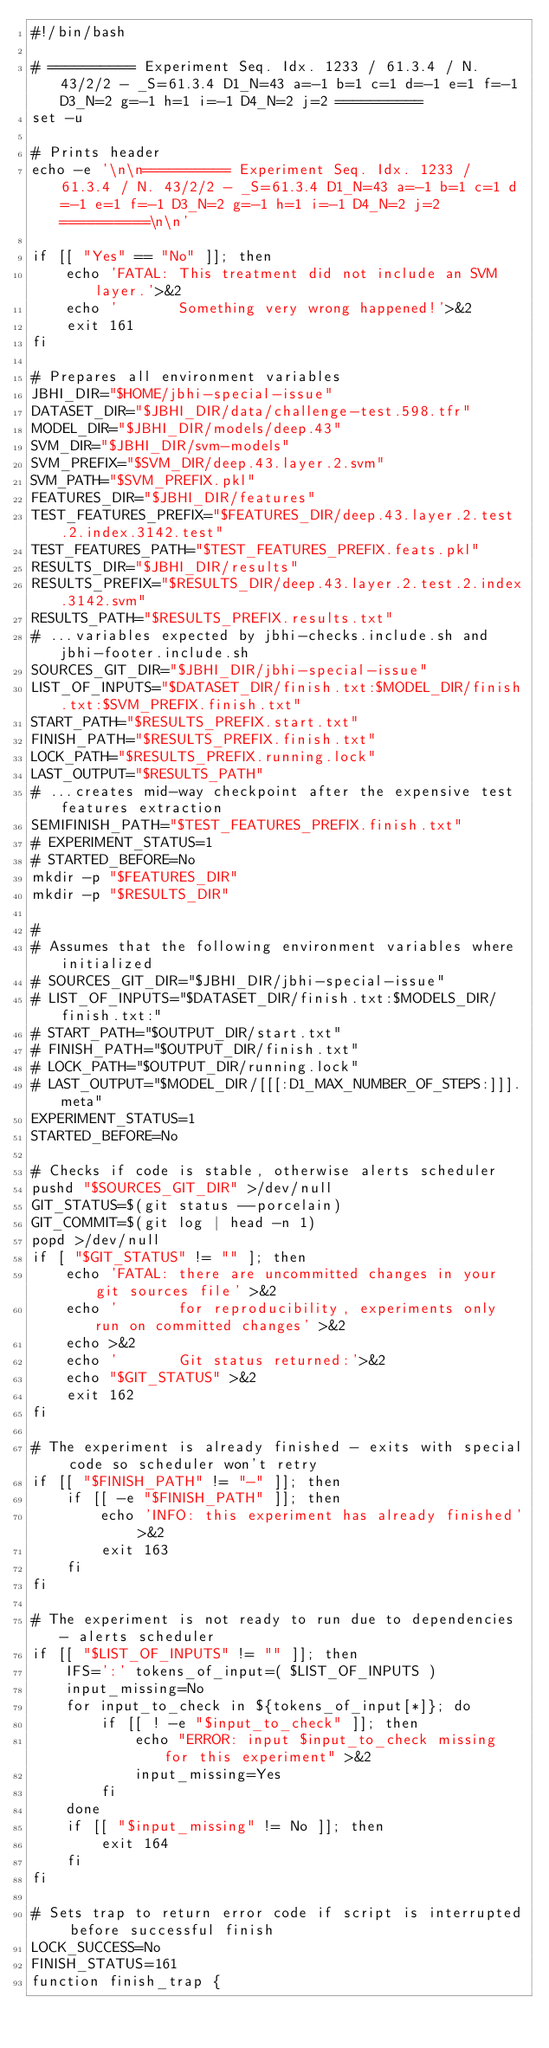<code> <loc_0><loc_0><loc_500><loc_500><_Bash_>#!/bin/bash

# ========== Experiment Seq. Idx. 1233 / 61.3.4 / N. 43/2/2 - _S=61.3.4 D1_N=43 a=-1 b=1 c=1 d=-1 e=1 f=-1 D3_N=2 g=-1 h=1 i=-1 D4_N=2 j=2 ==========
set -u

# Prints header
echo -e '\n\n========== Experiment Seq. Idx. 1233 / 61.3.4 / N. 43/2/2 - _S=61.3.4 D1_N=43 a=-1 b=1 c=1 d=-1 e=1 f=-1 D3_N=2 g=-1 h=1 i=-1 D4_N=2 j=2 ==========\n\n'

if [[ "Yes" == "No" ]]; then
    echo 'FATAL: This treatment did not include an SVM layer.'>&2
    echo '       Something very wrong happened!'>&2
    exit 161
fi

# Prepares all environment variables
JBHI_DIR="$HOME/jbhi-special-issue"
DATASET_DIR="$JBHI_DIR/data/challenge-test.598.tfr"
MODEL_DIR="$JBHI_DIR/models/deep.43"
SVM_DIR="$JBHI_DIR/svm-models"
SVM_PREFIX="$SVM_DIR/deep.43.layer.2.svm"
SVM_PATH="$SVM_PREFIX.pkl"
FEATURES_DIR="$JBHI_DIR/features"
TEST_FEATURES_PREFIX="$FEATURES_DIR/deep.43.layer.2.test.2.index.3142.test"
TEST_FEATURES_PATH="$TEST_FEATURES_PREFIX.feats.pkl"
RESULTS_DIR="$JBHI_DIR/results"
RESULTS_PREFIX="$RESULTS_DIR/deep.43.layer.2.test.2.index.3142.svm"
RESULTS_PATH="$RESULTS_PREFIX.results.txt"
# ...variables expected by jbhi-checks.include.sh and jbhi-footer.include.sh
SOURCES_GIT_DIR="$JBHI_DIR/jbhi-special-issue"
LIST_OF_INPUTS="$DATASET_DIR/finish.txt:$MODEL_DIR/finish.txt:$SVM_PREFIX.finish.txt"
START_PATH="$RESULTS_PREFIX.start.txt"
FINISH_PATH="$RESULTS_PREFIX.finish.txt"
LOCK_PATH="$RESULTS_PREFIX.running.lock"
LAST_OUTPUT="$RESULTS_PATH"
# ...creates mid-way checkpoint after the expensive test features extraction
SEMIFINISH_PATH="$TEST_FEATURES_PREFIX.finish.txt"
# EXPERIMENT_STATUS=1
# STARTED_BEFORE=No
mkdir -p "$FEATURES_DIR"
mkdir -p "$RESULTS_DIR"

#
# Assumes that the following environment variables where initialized
# SOURCES_GIT_DIR="$JBHI_DIR/jbhi-special-issue"
# LIST_OF_INPUTS="$DATASET_DIR/finish.txt:$MODELS_DIR/finish.txt:"
# START_PATH="$OUTPUT_DIR/start.txt"
# FINISH_PATH="$OUTPUT_DIR/finish.txt"
# LOCK_PATH="$OUTPUT_DIR/running.lock"
# LAST_OUTPUT="$MODEL_DIR/[[[:D1_MAX_NUMBER_OF_STEPS:]]].meta"
EXPERIMENT_STATUS=1
STARTED_BEFORE=No

# Checks if code is stable, otherwise alerts scheduler
pushd "$SOURCES_GIT_DIR" >/dev/null
GIT_STATUS=$(git status --porcelain)
GIT_COMMIT=$(git log | head -n 1)
popd >/dev/null
if [ "$GIT_STATUS" != "" ]; then
    echo 'FATAL: there are uncommitted changes in your git sources file' >&2
    echo '       for reproducibility, experiments only run on committed changes' >&2
    echo >&2
    echo '       Git status returned:'>&2
    echo "$GIT_STATUS" >&2
    exit 162
fi

# The experiment is already finished - exits with special code so scheduler won't retry
if [[ "$FINISH_PATH" != "-" ]]; then
    if [[ -e "$FINISH_PATH" ]]; then
        echo 'INFO: this experiment has already finished' >&2
        exit 163
    fi
fi

# The experiment is not ready to run due to dependencies - alerts scheduler
if [[ "$LIST_OF_INPUTS" != "" ]]; then
    IFS=':' tokens_of_input=( $LIST_OF_INPUTS )
    input_missing=No
    for input_to_check in ${tokens_of_input[*]}; do
        if [[ ! -e "$input_to_check" ]]; then
            echo "ERROR: input $input_to_check missing for this experiment" >&2
            input_missing=Yes
        fi
    done
    if [[ "$input_missing" != No ]]; then
        exit 164
    fi
fi

# Sets trap to return error code if script is interrupted before successful finish
LOCK_SUCCESS=No
FINISH_STATUS=161
function finish_trap {</code> 